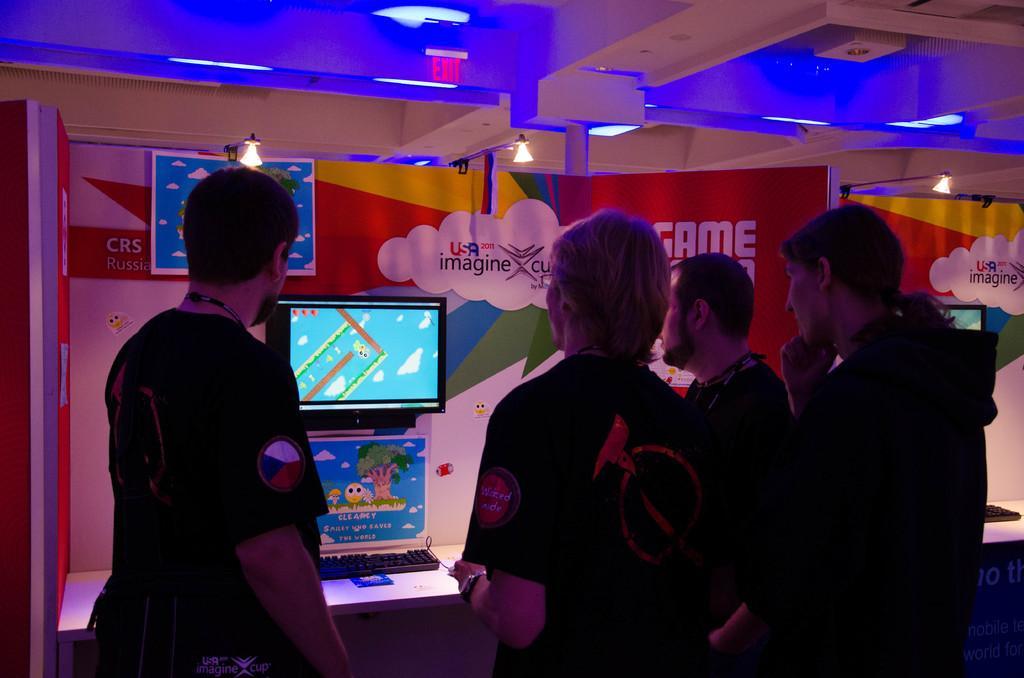Can you describe this image briefly? In the picture we can see some people are standing near to the desk on it we can see a keyboard and to the wall we can see a monitor and to the wall we can see some painting and to the ceiling we can see a exit board and some lights which are blue in color. 